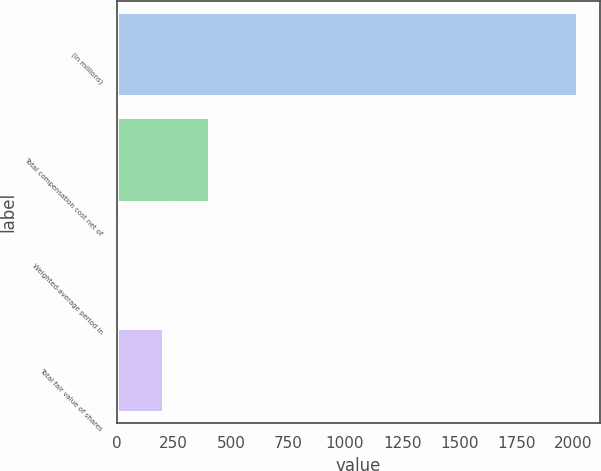<chart> <loc_0><loc_0><loc_500><loc_500><bar_chart><fcel>(in millions)<fcel>Total compensation cost net of<fcel>Weighted-average period in<fcel>Total fair value of shares<nl><fcel>2017<fcel>405<fcel>2<fcel>203.5<nl></chart> 